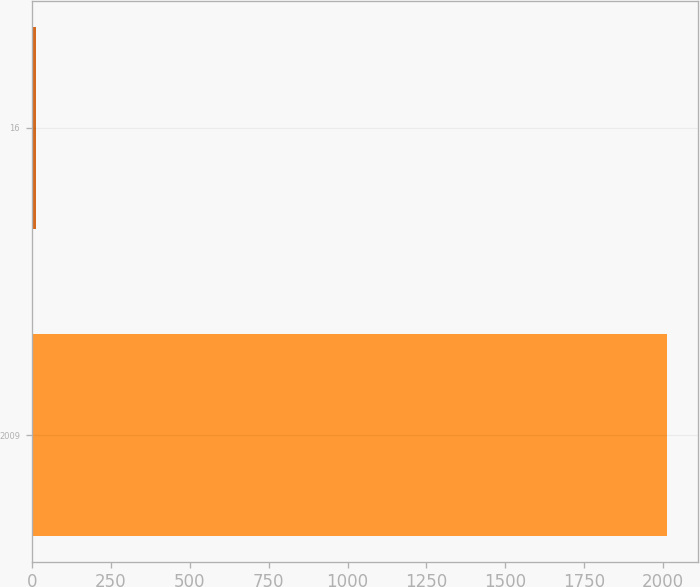<chart> <loc_0><loc_0><loc_500><loc_500><bar_chart><fcel>2009<fcel>16<nl><fcel>2011<fcel>14<nl></chart> 